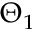<formula> <loc_0><loc_0><loc_500><loc_500>\Theta _ { 1 }</formula> 